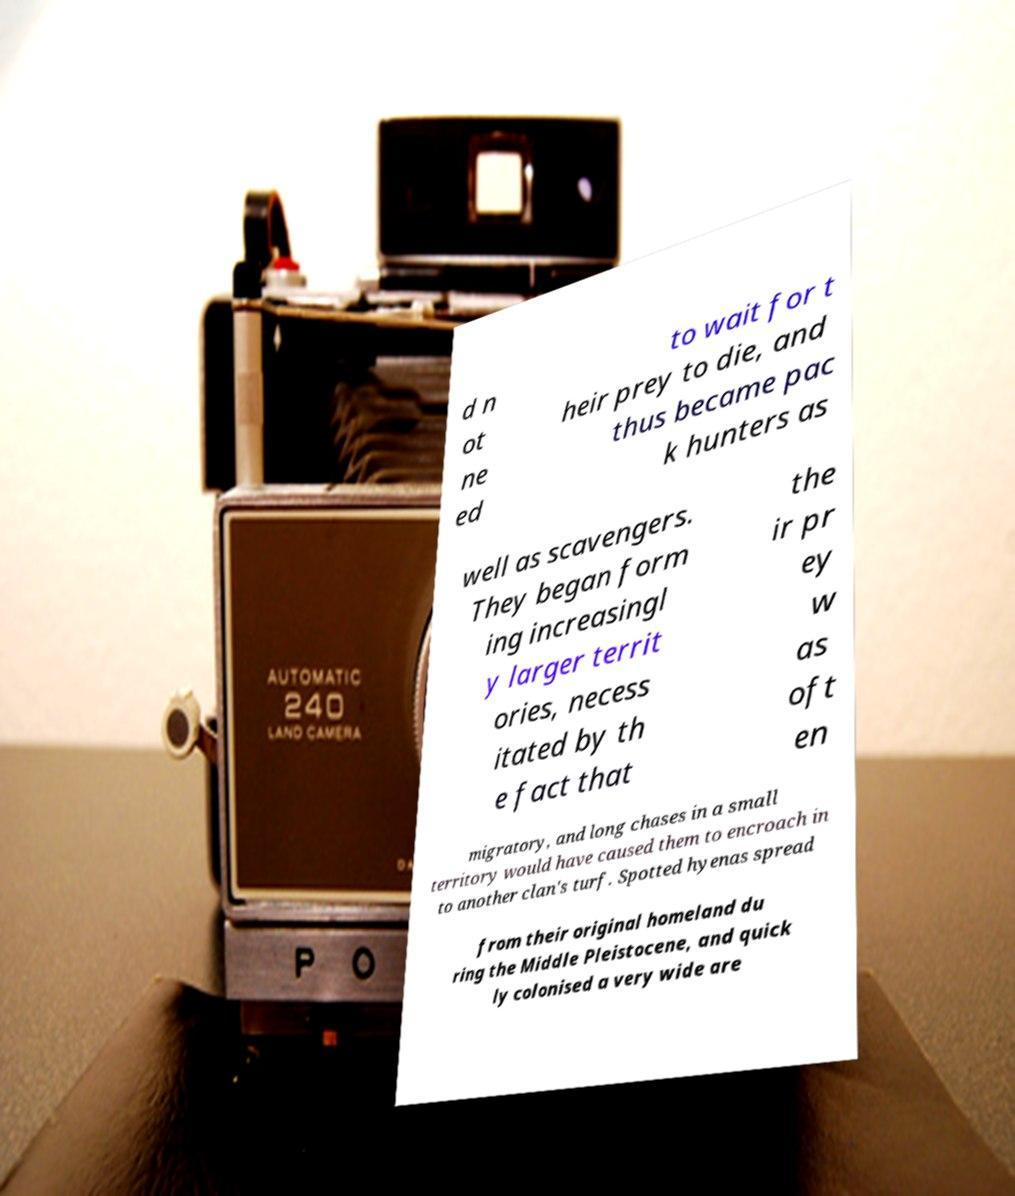Could you assist in decoding the text presented in this image and type it out clearly? d n ot ne ed to wait for t heir prey to die, and thus became pac k hunters as well as scavengers. They began form ing increasingl y larger territ ories, necess itated by th e fact that the ir pr ey w as oft en migratory, and long chases in a small territory would have caused them to encroach in to another clan's turf. Spotted hyenas spread from their original homeland du ring the Middle Pleistocene, and quick ly colonised a very wide are 